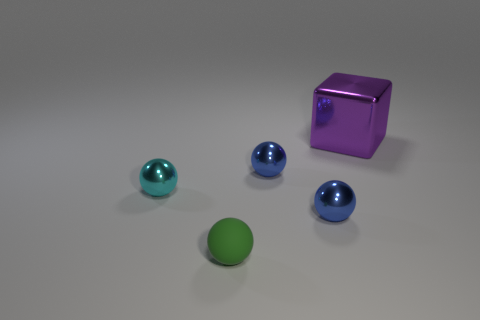Subtract all metal spheres. How many spheres are left? 1 Subtract all green spheres. How many spheres are left? 3 Add 2 large shiny cubes. How many objects exist? 7 Subtract all purple balls. Subtract all brown cylinders. How many balls are left? 4 Subtract all spheres. How many objects are left? 1 Add 1 green matte objects. How many green matte objects are left? 2 Add 5 large blue metallic cylinders. How many large blue metallic cylinders exist? 5 Subtract 0 red cubes. How many objects are left? 5 Subtract all tiny blue spheres. Subtract all cyan objects. How many objects are left? 2 